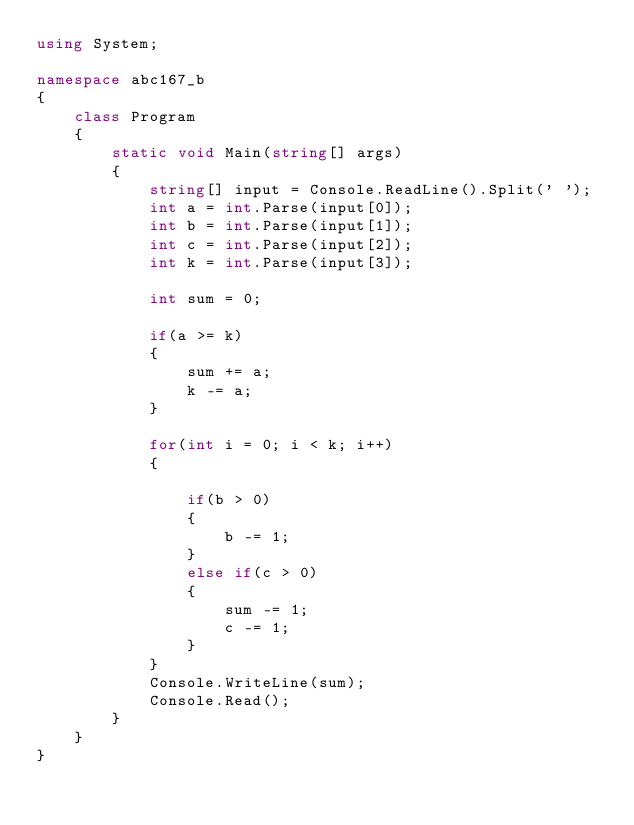<code> <loc_0><loc_0><loc_500><loc_500><_C#_>using System;

namespace abc167_b
{
    class Program
    {
        static void Main(string[] args)
        {
            string[] input = Console.ReadLine().Split(' ');
            int a = int.Parse(input[0]);
            int b = int.Parse(input[1]);
            int c = int.Parse(input[2]);
            int k = int.Parse(input[3]);

            int sum = 0;

            if(a >= k)
            {
                sum += a;
                k -= a;
            }

            for(int i = 0; i < k; i++)
            {

                if(b > 0)
                {
                    b -= 1;
                }
                else if(c > 0)
                {
                    sum -= 1;
                    c -= 1;
                }
            }
            Console.WriteLine(sum);
            Console.Read();
        }
    }
}
</code> 